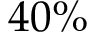Convert formula to latex. <formula><loc_0><loc_0><loc_500><loc_500>4 0 \%</formula> 